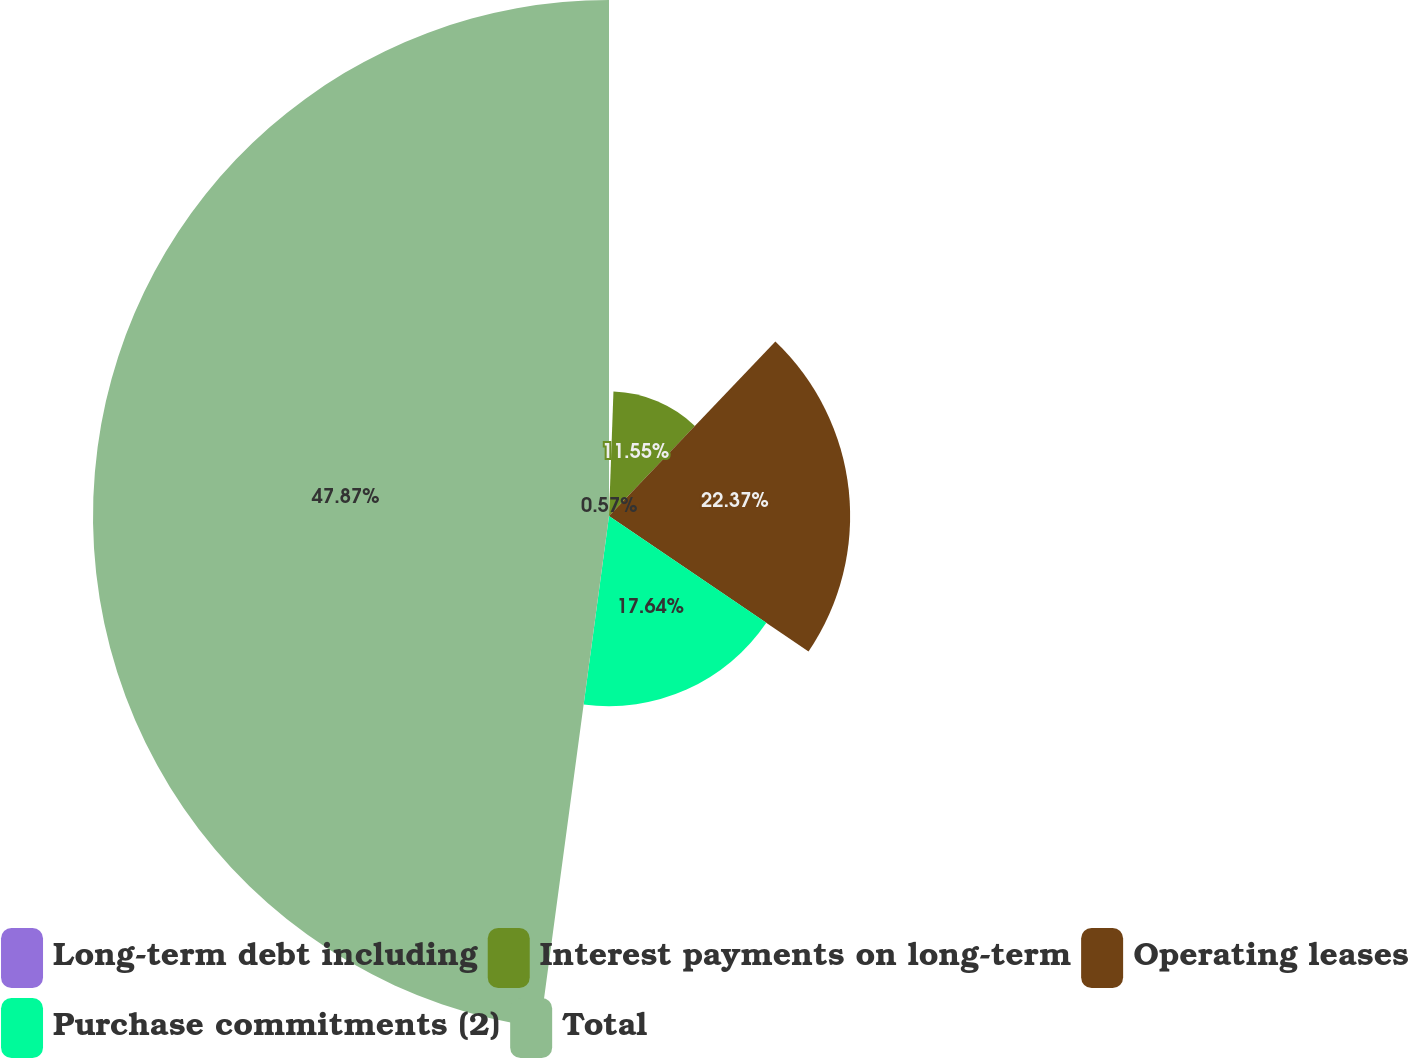Convert chart to OTSL. <chart><loc_0><loc_0><loc_500><loc_500><pie_chart><fcel>Long-term debt including<fcel>Interest payments on long-term<fcel>Operating leases<fcel>Purchase commitments (2)<fcel>Total<nl><fcel>0.57%<fcel>11.55%<fcel>22.37%<fcel>17.64%<fcel>47.87%<nl></chart> 